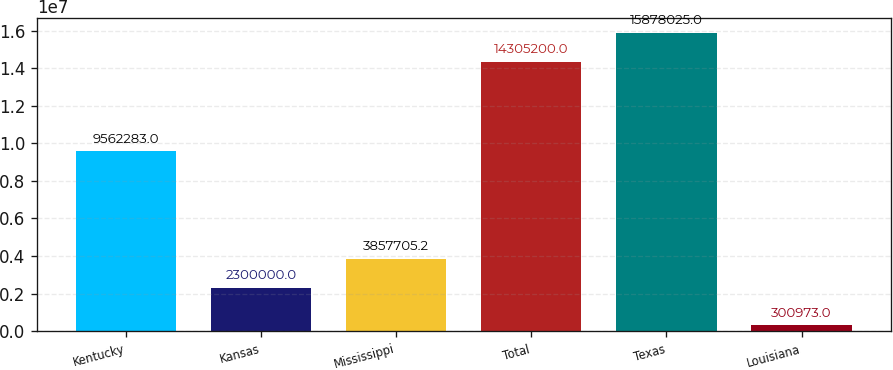Convert chart. <chart><loc_0><loc_0><loc_500><loc_500><bar_chart><fcel>Kentucky<fcel>Kansas<fcel>Mississippi<fcel>Total<fcel>Texas<fcel>Louisiana<nl><fcel>9.56228e+06<fcel>2.3e+06<fcel>3.85771e+06<fcel>1.43052e+07<fcel>1.5878e+07<fcel>300973<nl></chart> 